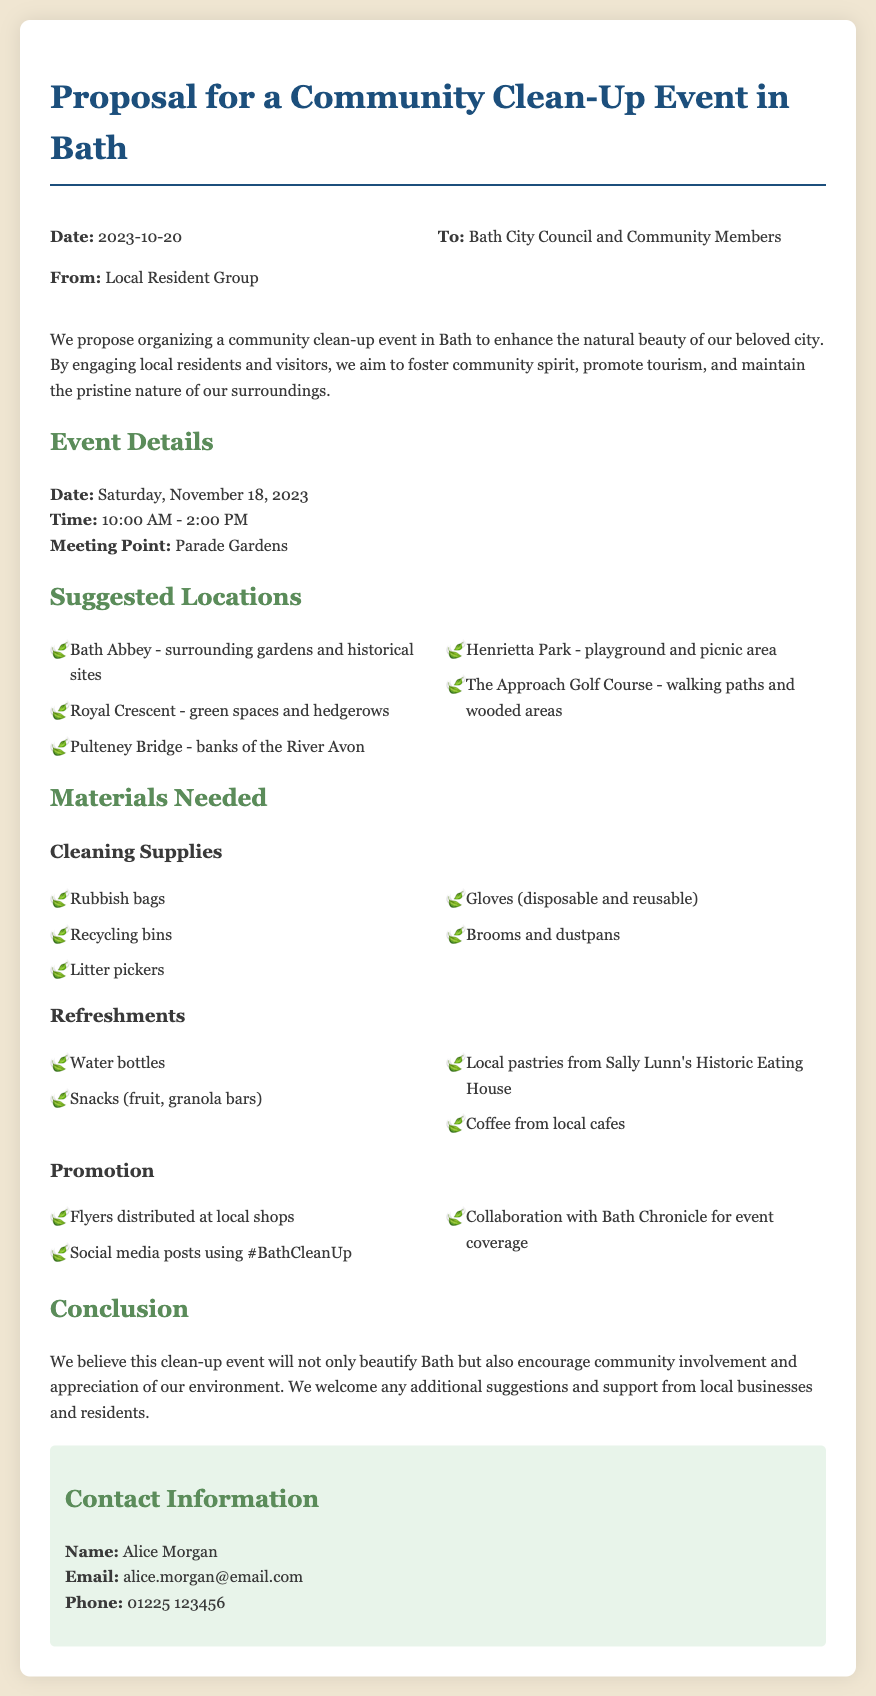What is the date of the community clean-up event? The date of the event is explicitly mentioned in the event details section of the document.
Answer: November 18, 2023 What time will the clean-up event start? The starting time is provided under the event details in the document.
Answer: 10:00 AM Where is the meeting point for the event? The document specifies the meeting point in the event details section.
Answer: Parade Gardens What are two suggested locations for the clean-up? The document lists several locations for the clean-up, which can be referenced to provide specific examples.
Answer: Bath Abbey, Royal Crescent What are the disposable materials needed for the event? The cleaning supplies section includes a list of required materials.
Answer: Gloves (disposable) What type of refreshments will be provided? The refreshments section outlines what will be available for participants during the event.
Answer: Water bottles How will the event be promoted? The document outlines various methods for promoting the event under a specific section.
Answer: Flyers distributed at local shops Who is the contact person for the event? The contact information section in the document clearly identifies the person responsible for inquiries related to the event.
Answer: Alice Morgan 